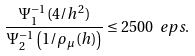<formula> <loc_0><loc_0><loc_500><loc_500>\frac { \Psi _ { 1 } ^ { - 1 } ( 4 / h ^ { 2 } ) } { \Psi _ { 2 } ^ { - 1 } \left ( 1 / \rho _ { \mu } ( h ) \right ) } \leq 2 5 0 0 \ e p s .</formula> 